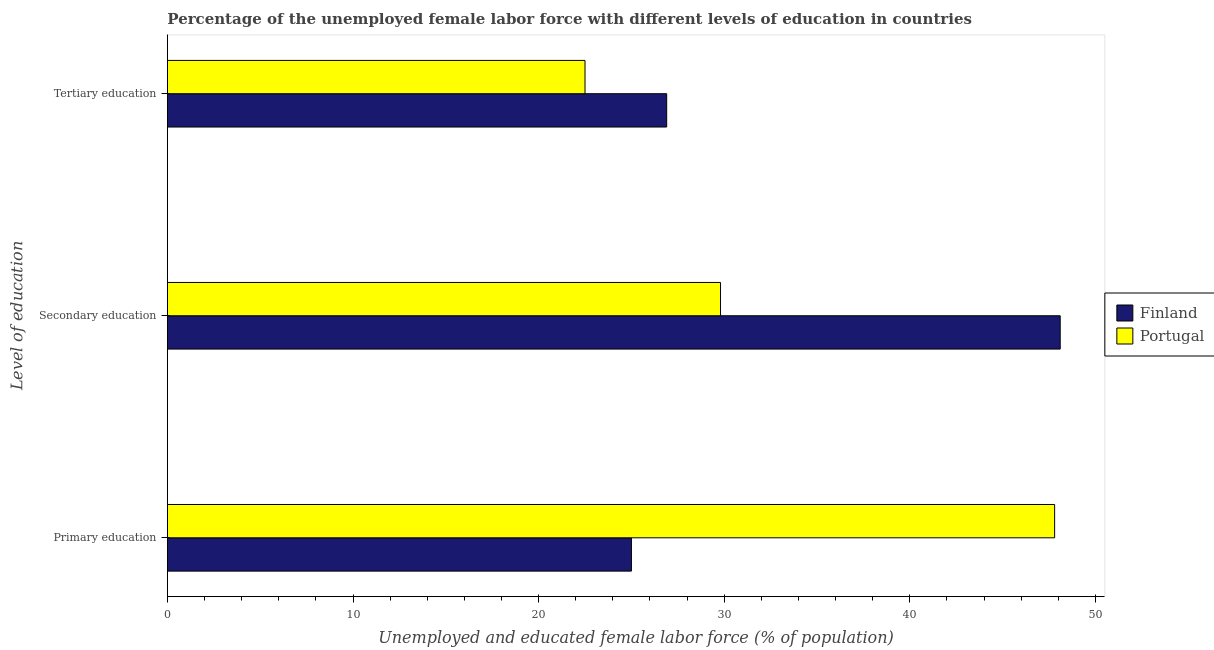How many different coloured bars are there?
Make the answer very short. 2. How many groups of bars are there?
Your response must be concise. 3. Are the number of bars per tick equal to the number of legend labels?
Give a very brief answer. Yes. Are the number of bars on each tick of the Y-axis equal?
Ensure brevity in your answer.  Yes. What is the label of the 1st group of bars from the top?
Ensure brevity in your answer.  Tertiary education. Across all countries, what is the maximum percentage of female labor force who received tertiary education?
Offer a terse response. 26.9. Across all countries, what is the minimum percentage of female labor force who received primary education?
Your answer should be very brief. 25. What is the total percentage of female labor force who received primary education in the graph?
Provide a succinct answer. 72.8. What is the difference between the percentage of female labor force who received secondary education in Finland and that in Portugal?
Your answer should be very brief. 18.3. What is the difference between the percentage of female labor force who received secondary education in Portugal and the percentage of female labor force who received tertiary education in Finland?
Make the answer very short. 2.9. What is the average percentage of female labor force who received secondary education per country?
Offer a very short reply. 38.95. What is the difference between the percentage of female labor force who received tertiary education and percentage of female labor force who received primary education in Portugal?
Give a very brief answer. -25.3. What is the ratio of the percentage of female labor force who received tertiary education in Finland to that in Portugal?
Ensure brevity in your answer.  1.2. Is the percentage of female labor force who received tertiary education in Portugal less than that in Finland?
Ensure brevity in your answer.  Yes. Is the difference between the percentage of female labor force who received secondary education in Portugal and Finland greater than the difference between the percentage of female labor force who received primary education in Portugal and Finland?
Provide a short and direct response. No. What is the difference between the highest and the second highest percentage of female labor force who received primary education?
Make the answer very short. 22.8. What is the difference between the highest and the lowest percentage of female labor force who received tertiary education?
Give a very brief answer. 4.4. In how many countries, is the percentage of female labor force who received secondary education greater than the average percentage of female labor force who received secondary education taken over all countries?
Your response must be concise. 1. Is the sum of the percentage of female labor force who received primary education in Finland and Portugal greater than the maximum percentage of female labor force who received tertiary education across all countries?
Provide a succinct answer. Yes. What does the 1st bar from the top in Primary education represents?
Your answer should be compact. Portugal. How many countries are there in the graph?
Your answer should be compact. 2. Does the graph contain grids?
Offer a terse response. No. Where does the legend appear in the graph?
Provide a short and direct response. Center right. How many legend labels are there?
Give a very brief answer. 2. How are the legend labels stacked?
Provide a succinct answer. Vertical. What is the title of the graph?
Ensure brevity in your answer.  Percentage of the unemployed female labor force with different levels of education in countries. Does "Channel Islands" appear as one of the legend labels in the graph?
Offer a very short reply. No. What is the label or title of the X-axis?
Ensure brevity in your answer.  Unemployed and educated female labor force (% of population). What is the label or title of the Y-axis?
Keep it short and to the point. Level of education. What is the Unemployed and educated female labor force (% of population) in Finland in Primary education?
Your response must be concise. 25. What is the Unemployed and educated female labor force (% of population) of Portugal in Primary education?
Ensure brevity in your answer.  47.8. What is the Unemployed and educated female labor force (% of population) of Finland in Secondary education?
Offer a very short reply. 48.1. What is the Unemployed and educated female labor force (% of population) of Portugal in Secondary education?
Give a very brief answer. 29.8. What is the Unemployed and educated female labor force (% of population) in Finland in Tertiary education?
Offer a terse response. 26.9. What is the Unemployed and educated female labor force (% of population) in Portugal in Tertiary education?
Give a very brief answer. 22.5. Across all Level of education, what is the maximum Unemployed and educated female labor force (% of population) in Finland?
Give a very brief answer. 48.1. Across all Level of education, what is the maximum Unemployed and educated female labor force (% of population) in Portugal?
Provide a short and direct response. 47.8. Across all Level of education, what is the minimum Unemployed and educated female labor force (% of population) in Finland?
Keep it short and to the point. 25. What is the total Unemployed and educated female labor force (% of population) in Finland in the graph?
Offer a terse response. 100. What is the total Unemployed and educated female labor force (% of population) in Portugal in the graph?
Offer a very short reply. 100.1. What is the difference between the Unemployed and educated female labor force (% of population) of Finland in Primary education and that in Secondary education?
Keep it short and to the point. -23.1. What is the difference between the Unemployed and educated female labor force (% of population) in Portugal in Primary education and that in Secondary education?
Provide a short and direct response. 18. What is the difference between the Unemployed and educated female labor force (% of population) of Portugal in Primary education and that in Tertiary education?
Your answer should be very brief. 25.3. What is the difference between the Unemployed and educated female labor force (% of population) of Finland in Secondary education and that in Tertiary education?
Your answer should be very brief. 21.2. What is the difference between the Unemployed and educated female labor force (% of population) of Finland in Primary education and the Unemployed and educated female labor force (% of population) of Portugal in Secondary education?
Keep it short and to the point. -4.8. What is the difference between the Unemployed and educated female labor force (% of population) in Finland in Secondary education and the Unemployed and educated female labor force (% of population) in Portugal in Tertiary education?
Provide a succinct answer. 25.6. What is the average Unemployed and educated female labor force (% of population) in Finland per Level of education?
Make the answer very short. 33.33. What is the average Unemployed and educated female labor force (% of population) in Portugal per Level of education?
Make the answer very short. 33.37. What is the difference between the Unemployed and educated female labor force (% of population) of Finland and Unemployed and educated female labor force (% of population) of Portugal in Primary education?
Offer a very short reply. -22.8. What is the difference between the Unemployed and educated female labor force (% of population) in Finland and Unemployed and educated female labor force (% of population) in Portugal in Tertiary education?
Your response must be concise. 4.4. What is the ratio of the Unemployed and educated female labor force (% of population) of Finland in Primary education to that in Secondary education?
Provide a short and direct response. 0.52. What is the ratio of the Unemployed and educated female labor force (% of population) in Portugal in Primary education to that in Secondary education?
Provide a succinct answer. 1.6. What is the ratio of the Unemployed and educated female labor force (% of population) of Finland in Primary education to that in Tertiary education?
Offer a terse response. 0.93. What is the ratio of the Unemployed and educated female labor force (% of population) of Portugal in Primary education to that in Tertiary education?
Offer a very short reply. 2.12. What is the ratio of the Unemployed and educated female labor force (% of population) of Finland in Secondary education to that in Tertiary education?
Offer a very short reply. 1.79. What is the ratio of the Unemployed and educated female labor force (% of population) of Portugal in Secondary education to that in Tertiary education?
Make the answer very short. 1.32. What is the difference between the highest and the second highest Unemployed and educated female labor force (% of population) of Finland?
Ensure brevity in your answer.  21.2. What is the difference between the highest and the lowest Unemployed and educated female labor force (% of population) of Finland?
Give a very brief answer. 23.1. What is the difference between the highest and the lowest Unemployed and educated female labor force (% of population) of Portugal?
Provide a short and direct response. 25.3. 